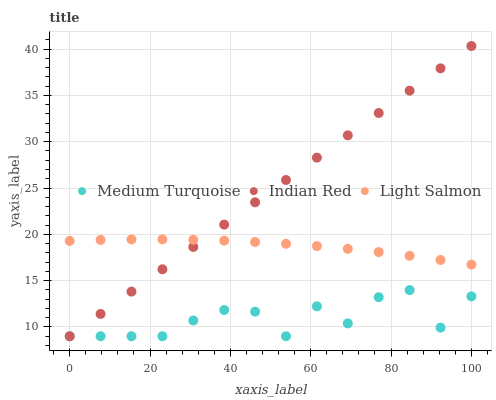Does Medium Turquoise have the minimum area under the curve?
Answer yes or no. Yes. Does Indian Red have the maximum area under the curve?
Answer yes or no. Yes. Does Indian Red have the minimum area under the curve?
Answer yes or no. No. Does Medium Turquoise have the maximum area under the curve?
Answer yes or no. No. Is Indian Red the smoothest?
Answer yes or no. Yes. Is Medium Turquoise the roughest?
Answer yes or no. Yes. Is Medium Turquoise the smoothest?
Answer yes or no. No. Is Indian Red the roughest?
Answer yes or no. No. Does Indian Red have the lowest value?
Answer yes or no. Yes. Does Indian Red have the highest value?
Answer yes or no. Yes. Does Medium Turquoise have the highest value?
Answer yes or no. No. Is Medium Turquoise less than Light Salmon?
Answer yes or no. Yes. Is Light Salmon greater than Medium Turquoise?
Answer yes or no. Yes. Does Medium Turquoise intersect Indian Red?
Answer yes or no. Yes. Is Medium Turquoise less than Indian Red?
Answer yes or no. No. Is Medium Turquoise greater than Indian Red?
Answer yes or no. No. Does Medium Turquoise intersect Light Salmon?
Answer yes or no. No. 